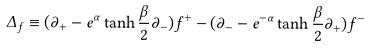<formula> <loc_0><loc_0><loc_500><loc_500>\Delta _ { f } \equiv ( \partial _ { + } - e ^ { \alpha } \tanh \frac { \beta } { 2 } \partial _ { - } ) f ^ { + } - ( \partial _ { - } - e ^ { - \alpha } \tanh \frac { \beta } { 2 } \partial _ { + } ) f ^ { - }</formula> 